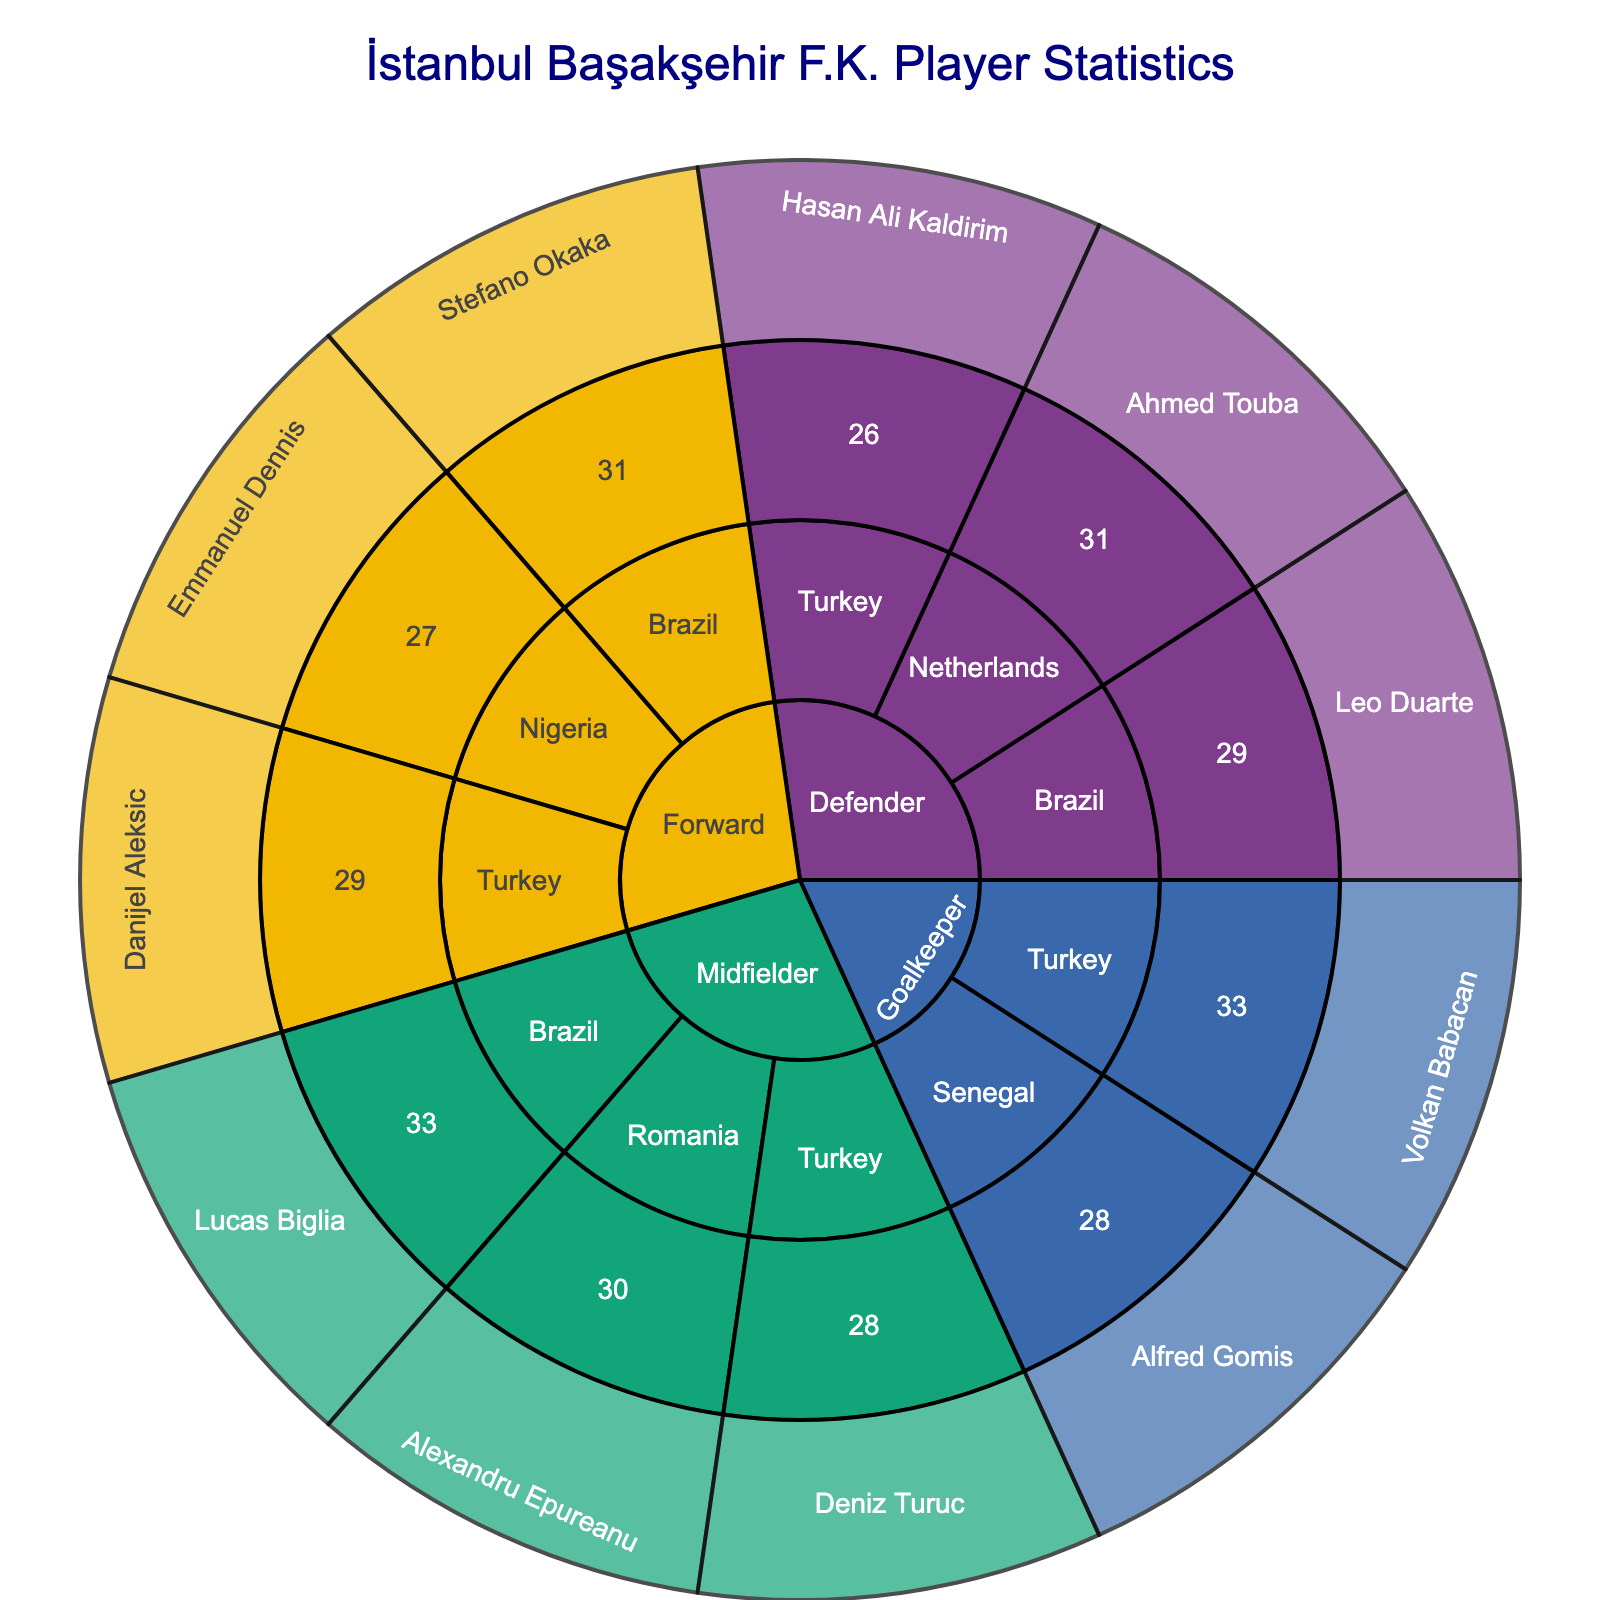What's the title of the plot? Look at the top of the figure where the title is located.
Answer: İstanbul Başakşehir F.K. Player Statistics How many midfielders are there? Identify the 'Midfielder' node in the plot and count the number of players branching from it.
Answer: 3 Which nationality has the most defenders? Look at the 'Defender' node and check which nationality has the most players branching out.
Answer: Turkey What is the average age of the forwards? There are three forwards: Danijel Aleksic (29), Stefano Okaka (31), and Emmanuel Dennis (27). Sum their ages (29+31+27) = 87. Divide by the number of forwards (3).
Answer: 29 Which position has the oldest player from Brazil? Look at the 'Brazil' nodes and find the positions and ages: Lucas Biglia (Midfielder, 33) and Leo Duarte (Defender, 29).
Answer: Midfielder How many nationalities are represented in the goalkeeper position? Check the branches under the 'Goalkeeper' node and count the distinct nationalities.
Answer: 2 Which Turkish player is a midfielder and what is their age? Navigate to the 'Midfielder' node, find 'Turkey' under it, and check the player and age details.
Answer: Deniz Turuc, 28 Who's the youngest Brazilian player and what position do they play? Look at the Brazilian entries and identify the youngest player and their position: Lucas Biglia (33) and Leo Duarte (29).
Answer: Leo Duarte, Defender Is there any player older than 31 who is not a goalkeeper? Check all the nodes for ages above 31 and positions: Stefano Okaka (Forward, 31), Alexandru Epureanu (Midfielder, 30), Lucas Biglia (Midfielder, 33), and Volkan Babacan (Goalkeeper, 33). Only Lucas Biglia fits the criteria.
Answer: Yes, Lucas Biglia Which position has the player with the lowest age? Identify the player with the lowest age across all nodes and note their position: Emmanuel Dennis (Forward, 27).
Answer: Forward 